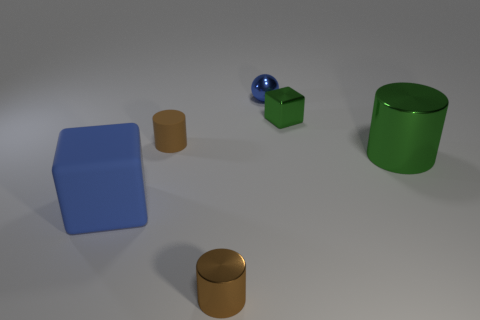Add 1 large cylinders. How many objects exist? 7 Subtract all blocks. How many objects are left? 4 Subtract 0 green spheres. How many objects are left? 6 Subtract all green blocks. Subtract all green shiny cubes. How many objects are left? 4 Add 6 brown metal cylinders. How many brown metal cylinders are left? 7 Add 2 small purple rubber balls. How many small purple rubber balls exist? 2 